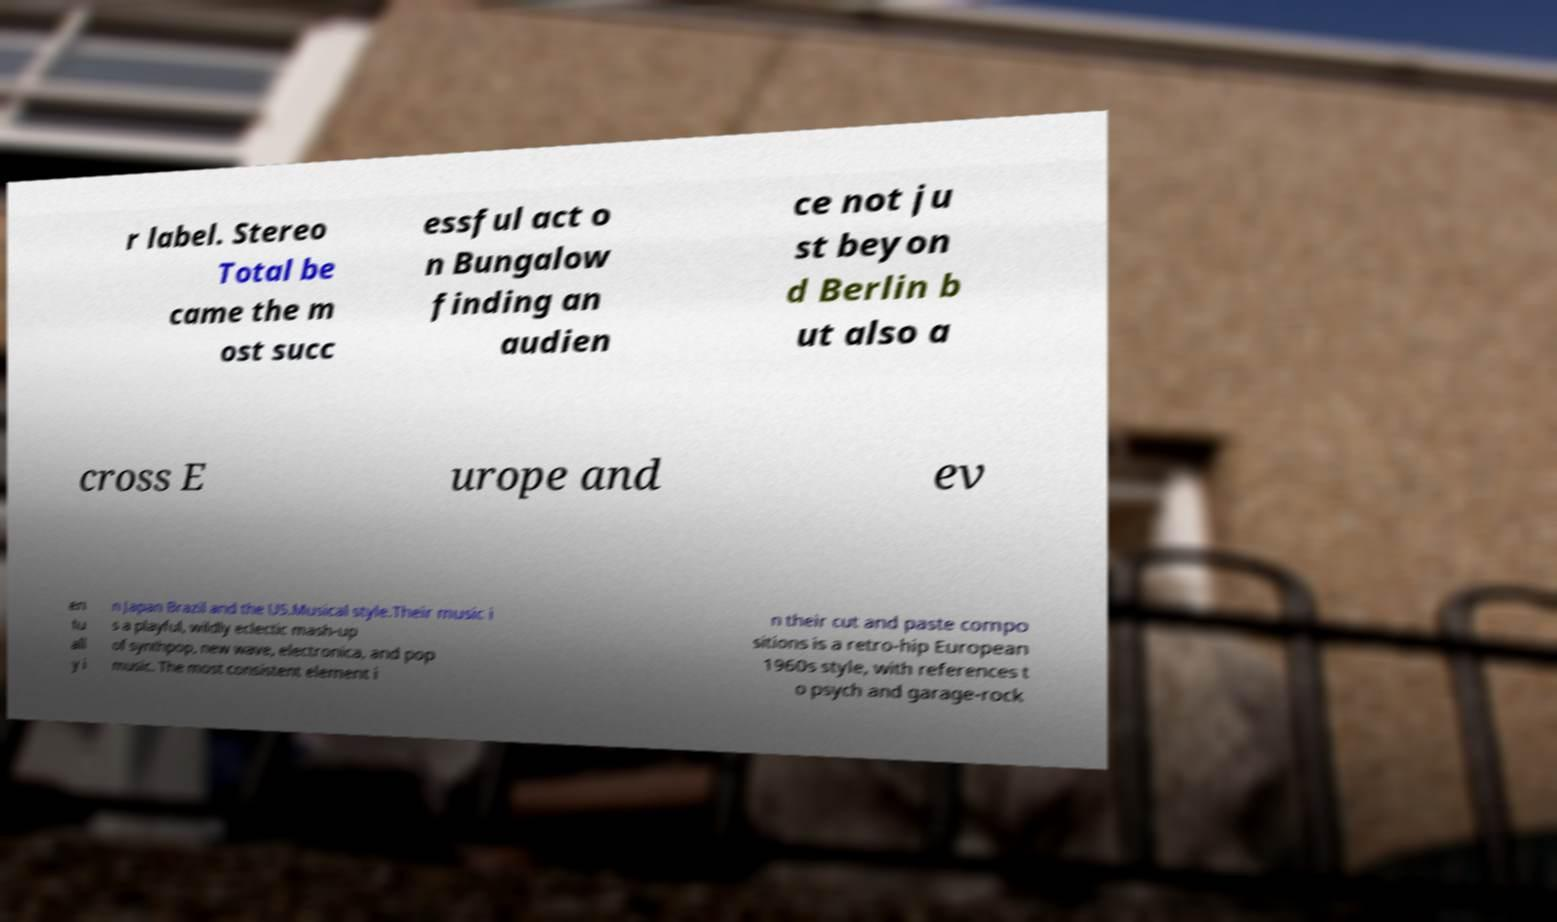Could you assist in decoding the text presented in this image and type it out clearly? r label. Stereo Total be came the m ost succ essful act o n Bungalow finding an audien ce not ju st beyon d Berlin b ut also a cross E urope and ev en tu all y i n Japan Brazil and the US.Musical style.Their music i s a playful, wildly eclectic mash-up of synthpop, new wave, electronica, and pop music. The most consistent element i n their cut and paste compo sitions is a retro-hip European 1960s style, with references t o psych and garage-rock 